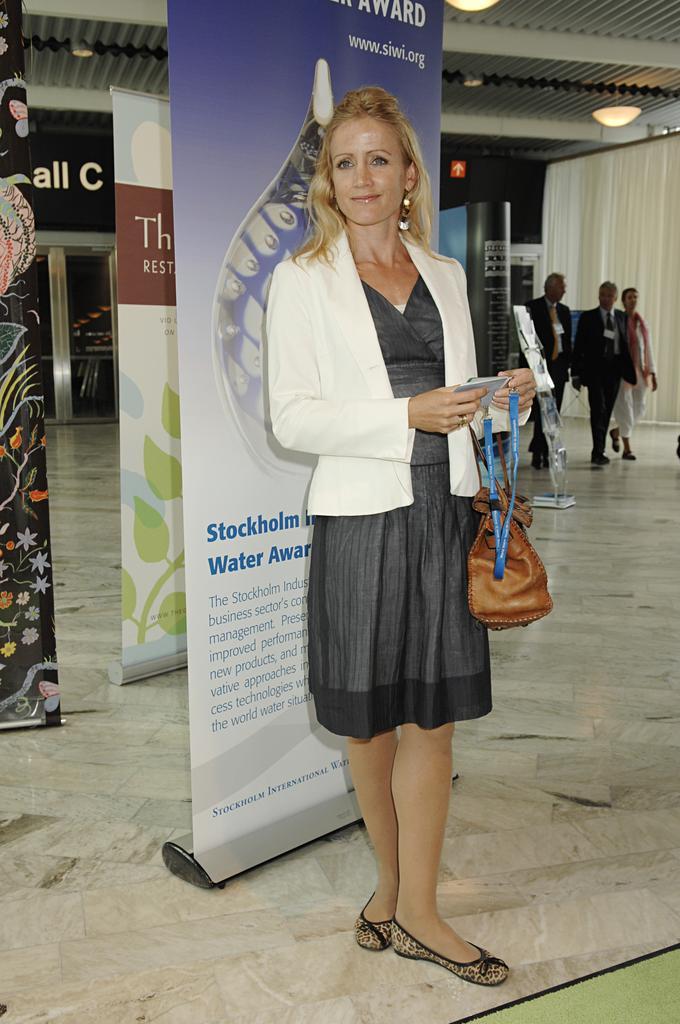Describe this image in one or two sentences. In the center of the image we can see a woman wearing the bag and holding the tag and standing on the floor and smiling. In the background we can see the people walking. We can also see the banners with the text. Image also consists of the door and also the ceiling with the lights. We can also see the curtain. 